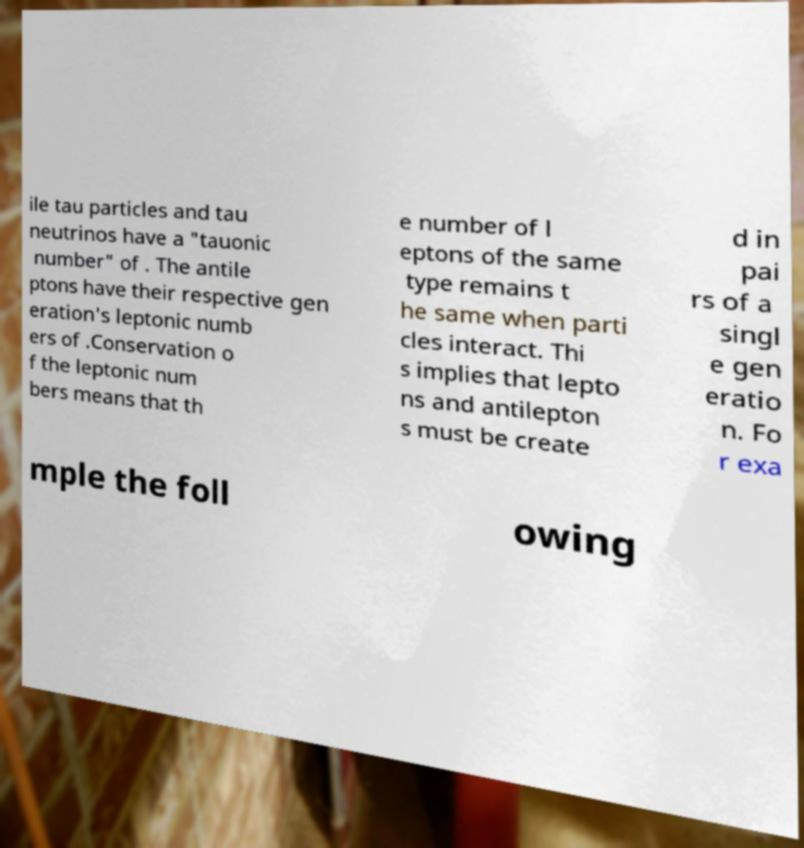Can you accurately transcribe the text from the provided image for me? ile tau particles and tau neutrinos have a "tauonic number" of . The antile ptons have their respective gen eration's leptonic numb ers of .Conservation o f the leptonic num bers means that th e number of l eptons of the same type remains t he same when parti cles interact. Thi s implies that lepto ns and antilepton s must be create d in pai rs of a singl e gen eratio n. Fo r exa mple the foll owing 